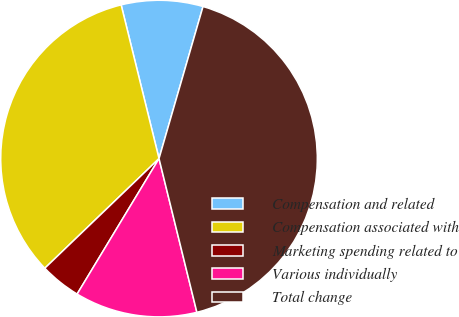Convert chart. <chart><loc_0><loc_0><loc_500><loc_500><pie_chart><fcel>Compensation and related<fcel>Compensation associated with<fcel>Marketing spending related to<fcel>Various individually<fcel>Total change<nl><fcel>8.33%<fcel>33.33%<fcel>4.17%<fcel>12.5%<fcel>41.67%<nl></chart> 